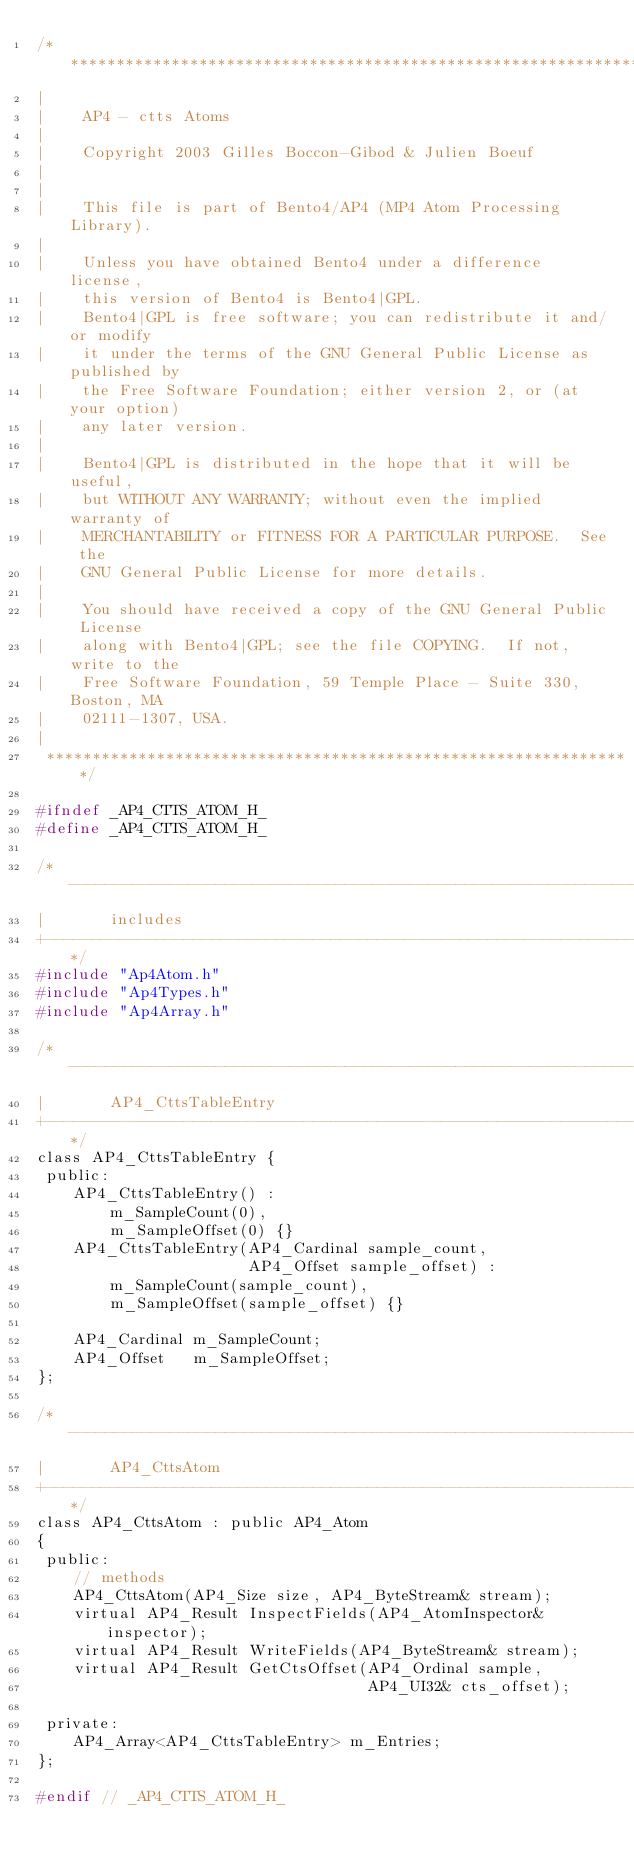Convert code to text. <code><loc_0><loc_0><loc_500><loc_500><_C_>/*****************************************************************
|
|    AP4 - ctts Atoms 
|
|    Copyright 2003 Gilles Boccon-Gibod & Julien Boeuf
|
|
|    This file is part of Bento4/AP4 (MP4 Atom Processing Library).
|
|    Unless you have obtained Bento4 under a difference license,
|    this version of Bento4 is Bento4|GPL.
|    Bento4|GPL is free software; you can redistribute it and/or modify
|    it under the terms of the GNU General Public License as published by
|    the Free Software Foundation; either version 2, or (at your option)
|    any later version.
|
|    Bento4|GPL is distributed in the hope that it will be useful,
|    but WITHOUT ANY WARRANTY; without even the implied warranty of
|    MERCHANTABILITY or FITNESS FOR A PARTICULAR PURPOSE.  See the
|    GNU General Public License for more details.
|
|    You should have received a copy of the GNU General Public License
|    along with Bento4|GPL; see the file COPYING.  If not, write to the
|    Free Software Foundation, 59 Temple Place - Suite 330, Boston, MA
|    02111-1307, USA.
|
 ****************************************************************/

#ifndef _AP4_CTTS_ATOM_H_
#define _AP4_CTTS_ATOM_H_

/*----------------------------------------------------------------------
|       includes
+---------------------------------------------------------------------*/
#include "Ap4Atom.h"
#include "Ap4Types.h"
#include "Ap4Array.h"

/*----------------------------------------------------------------------
|       AP4_CttsTableEntry
+---------------------------------------------------------------------*/
class AP4_CttsTableEntry {
 public:
    AP4_CttsTableEntry() : 
        m_SampleCount(0), 
        m_SampleOffset(0) {}
    AP4_CttsTableEntry(AP4_Cardinal sample_count,
                       AP4_Offset sample_offset) :
        m_SampleCount(sample_count),
        m_SampleOffset(sample_offset) {}

    AP4_Cardinal m_SampleCount;
    AP4_Offset   m_SampleOffset;
};

/*----------------------------------------------------------------------
|       AP4_CttsAtom
+---------------------------------------------------------------------*/
class AP4_CttsAtom : public AP4_Atom
{
 public:
    // methods
    AP4_CttsAtom(AP4_Size size, AP4_ByteStream& stream);
    virtual AP4_Result InspectFields(AP4_AtomInspector& inspector);
    virtual AP4_Result WriteFields(AP4_ByteStream& stream);
    virtual AP4_Result GetCtsOffset(AP4_Ordinal sample, 
                                    AP4_UI32& cts_offset);

 private:
    AP4_Array<AP4_CttsTableEntry> m_Entries;
};

#endif // _AP4_CTTS_ATOM_H_
</code> 